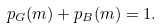Convert formula to latex. <formula><loc_0><loc_0><loc_500><loc_500>p _ { G } ( m ) + p _ { B } ( m ) = 1 .</formula> 